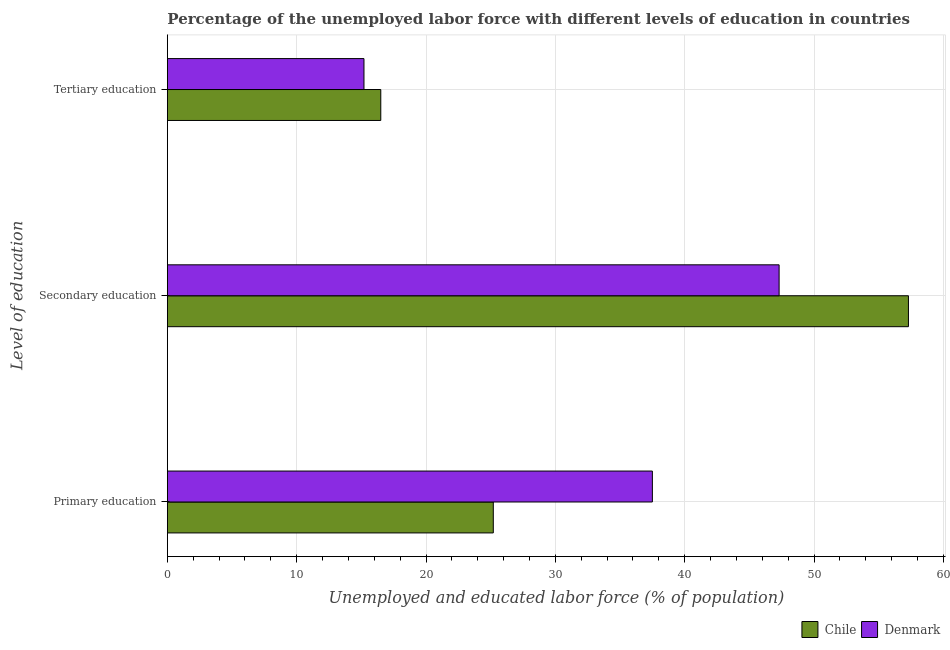How many different coloured bars are there?
Provide a short and direct response. 2. Are the number of bars per tick equal to the number of legend labels?
Give a very brief answer. Yes. How many bars are there on the 3rd tick from the top?
Offer a terse response. 2. What is the label of the 2nd group of bars from the top?
Your answer should be very brief. Secondary education. What is the percentage of labor force who received secondary education in Denmark?
Your answer should be compact. 47.3. Across all countries, what is the minimum percentage of labor force who received tertiary education?
Keep it short and to the point. 15.2. In which country was the percentage of labor force who received tertiary education maximum?
Your answer should be very brief. Chile. What is the total percentage of labor force who received primary education in the graph?
Your answer should be compact. 62.7. What is the difference between the percentage of labor force who received secondary education in Denmark and the percentage of labor force who received primary education in Chile?
Your response must be concise. 22.1. What is the average percentage of labor force who received primary education per country?
Offer a very short reply. 31.35. What is the difference between the percentage of labor force who received tertiary education and percentage of labor force who received primary education in Chile?
Give a very brief answer. -8.7. In how many countries, is the percentage of labor force who received secondary education greater than 8 %?
Offer a very short reply. 2. What is the ratio of the percentage of labor force who received primary education in Chile to that in Denmark?
Provide a succinct answer. 0.67. Is the difference between the percentage of labor force who received tertiary education in Denmark and Chile greater than the difference between the percentage of labor force who received secondary education in Denmark and Chile?
Your response must be concise. Yes. What is the difference between the highest and the second highest percentage of labor force who received tertiary education?
Ensure brevity in your answer.  1.3. What is the difference between the highest and the lowest percentage of labor force who received tertiary education?
Your answer should be very brief. 1.3. In how many countries, is the percentage of labor force who received tertiary education greater than the average percentage of labor force who received tertiary education taken over all countries?
Provide a short and direct response. 1. Is the sum of the percentage of labor force who received tertiary education in Chile and Denmark greater than the maximum percentage of labor force who received secondary education across all countries?
Your answer should be compact. No. What does the 1st bar from the top in Primary education represents?
Provide a succinct answer. Denmark. Are the values on the major ticks of X-axis written in scientific E-notation?
Provide a short and direct response. No. Does the graph contain any zero values?
Give a very brief answer. No. Does the graph contain grids?
Keep it short and to the point. Yes. Where does the legend appear in the graph?
Offer a terse response. Bottom right. How many legend labels are there?
Give a very brief answer. 2. How are the legend labels stacked?
Provide a succinct answer. Horizontal. What is the title of the graph?
Keep it short and to the point. Percentage of the unemployed labor force with different levels of education in countries. Does "Tuvalu" appear as one of the legend labels in the graph?
Ensure brevity in your answer.  No. What is the label or title of the X-axis?
Make the answer very short. Unemployed and educated labor force (% of population). What is the label or title of the Y-axis?
Provide a short and direct response. Level of education. What is the Unemployed and educated labor force (% of population) in Chile in Primary education?
Offer a terse response. 25.2. What is the Unemployed and educated labor force (% of population) in Denmark in Primary education?
Provide a short and direct response. 37.5. What is the Unemployed and educated labor force (% of population) in Chile in Secondary education?
Your answer should be very brief. 57.3. What is the Unemployed and educated labor force (% of population) of Denmark in Secondary education?
Provide a short and direct response. 47.3. What is the Unemployed and educated labor force (% of population) of Chile in Tertiary education?
Give a very brief answer. 16.5. What is the Unemployed and educated labor force (% of population) in Denmark in Tertiary education?
Your answer should be very brief. 15.2. Across all Level of education, what is the maximum Unemployed and educated labor force (% of population) of Chile?
Your response must be concise. 57.3. Across all Level of education, what is the maximum Unemployed and educated labor force (% of population) in Denmark?
Provide a short and direct response. 47.3. Across all Level of education, what is the minimum Unemployed and educated labor force (% of population) in Denmark?
Your response must be concise. 15.2. What is the difference between the Unemployed and educated labor force (% of population) of Chile in Primary education and that in Secondary education?
Offer a very short reply. -32.1. What is the difference between the Unemployed and educated labor force (% of population) in Chile in Primary education and that in Tertiary education?
Offer a terse response. 8.7. What is the difference between the Unemployed and educated labor force (% of population) of Denmark in Primary education and that in Tertiary education?
Provide a succinct answer. 22.3. What is the difference between the Unemployed and educated labor force (% of population) in Chile in Secondary education and that in Tertiary education?
Offer a very short reply. 40.8. What is the difference between the Unemployed and educated labor force (% of population) in Denmark in Secondary education and that in Tertiary education?
Ensure brevity in your answer.  32.1. What is the difference between the Unemployed and educated labor force (% of population) of Chile in Primary education and the Unemployed and educated labor force (% of population) of Denmark in Secondary education?
Offer a terse response. -22.1. What is the difference between the Unemployed and educated labor force (% of population) in Chile in Secondary education and the Unemployed and educated labor force (% of population) in Denmark in Tertiary education?
Ensure brevity in your answer.  42.1. What is the average Unemployed and educated labor force (% of population) in Chile per Level of education?
Make the answer very short. 33. What is the average Unemployed and educated labor force (% of population) in Denmark per Level of education?
Provide a succinct answer. 33.33. What is the difference between the Unemployed and educated labor force (% of population) of Chile and Unemployed and educated labor force (% of population) of Denmark in Tertiary education?
Make the answer very short. 1.3. What is the ratio of the Unemployed and educated labor force (% of population) of Chile in Primary education to that in Secondary education?
Your answer should be compact. 0.44. What is the ratio of the Unemployed and educated labor force (% of population) of Denmark in Primary education to that in Secondary education?
Provide a succinct answer. 0.79. What is the ratio of the Unemployed and educated labor force (% of population) of Chile in Primary education to that in Tertiary education?
Offer a very short reply. 1.53. What is the ratio of the Unemployed and educated labor force (% of population) of Denmark in Primary education to that in Tertiary education?
Your response must be concise. 2.47. What is the ratio of the Unemployed and educated labor force (% of population) in Chile in Secondary education to that in Tertiary education?
Your response must be concise. 3.47. What is the ratio of the Unemployed and educated labor force (% of population) in Denmark in Secondary education to that in Tertiary education?
Keep it short and to the point. 3.11. What is the difference between the highest and the second highest Unemployed and educated labor force (% of population) of Chile?
Offer a very short reply. 32.1. What is the difference between the highest and the lowest Unemployed and educated labor force (% of population) of Chile?
Your response must be concise. 40.8. What is the difference between the highest and the lowest Unemployed and educated labor force (% of population) of Denmark?
Your answer should be compact. 32.1. 